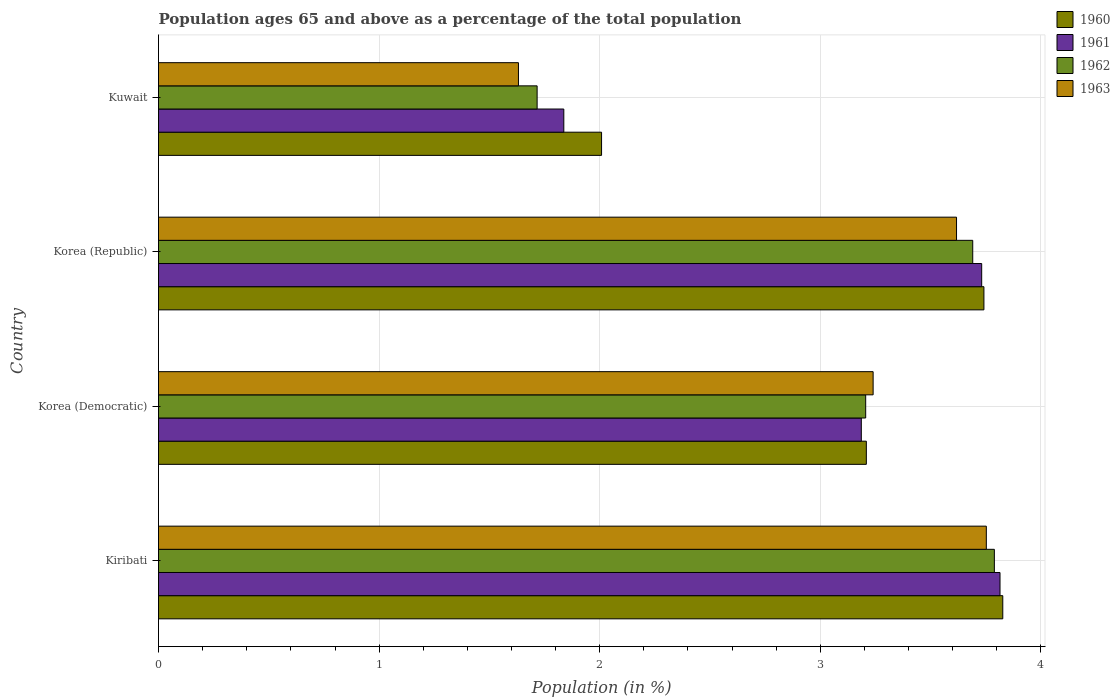How many different coloured bars are there?
Offer a terse response. 4. How many bars are there on the 4th tick from the top?
Ensure brevity in your answer.  4. What is the label of the 3rd group of bars from the top?
Give a very brief answer. Korea (Democratic). In how many cases, is the number of bars for a given country not equal to the number of legend labels?
Offer a very short reply. 0. What is the percentage of the population ages 65 and above in 1961 in Kuwait?
Keep it short and to the point. 1.84. Across all countries, what is the maximum percentage of the population ages 65 and above in 1962?
Your response must be concise. 3.79. Across all countries, what is the minimum percentage of the population ages 65 and above in 1963?
Your response must be concise. 1.63. In which country was the percentage of the population ages 65 and above in 1963 maximum?
Your answer should be compact. Kiribati. In which country was the percentage of the population ages 65 and above in 1962 minimum?
Provide a short and direct response. Kuwait. What is the total percentage of the population ages 65 and above in 1963 in the graph?
Give a very brief answer. 12.24. What is the difference between the percentage of the population ages 65 and above in 1960 in Korea (Democratic) and that in Korea (Republic)?
Your answer should be compact. -0.53. What is the difference between the percentage of the population ages 65 and above in 1961 in Kuwait and the percentage of the population ages 65 and above in 1962 in Korea (Republic)?
Make the answer very short. -1.85. What is the average percentage of the population ages 65 and above in 1961 per country?
Your response must be concise. 3.14. What is the difference between the percentage of the population ages 65 and above in 1961 and percentage of the population ages 65 and above in 1963 in Kuwait?
Your answer should be compact. 0.21. In how many countries, is the percentage of the population ages 65 and above in 1960 greater than 1.6 ?
Provide a succinct answer. 4. What is the ratio of the percentage of the population ages 65 and above in 1962 in Korea (Democratic) to that in Kuwait?
Make the answer very short. 1.87. Is the percentage of the population ages 65 and above in 1960 in Korea (Democratic) less than that in Korea (Republic)?
Provide a short and direct response. Yes. Is the difference between the percentage of the population ages 65 and above in 1961 in Korea (Democratic) and Kuwait greater than the difference between the percentage of the population ages 65 and above in 1963 in Korea (Democratic) and Kuwait?
Your answer should be compact. No. What is the difference between the highest and the second highest percentage of the population ages 65 and above in 1960?
Make the answer very short. 0.09. What is the difference between the highest and the lowest percentage of the population ages 65 and above in 1960?
Your response must be concise. 1.82. In how many countries, is the percentage of the population ages 65 and above in 1963 greater than the average percentage of the population ages 65 and above in 1963 taken over all countries?
Keep it short and to the point. 3. Is it the case that in every country, the sum of the percentage of the population ages 65 and above in 1961 and percentage of the population ages 65 and above in 1960 is greater than the sum of percentage of the population ages 65 and above in 1962 and percentage of the population ages 65 and above in 1963?
Your answer should be very brief. No. What does the 2nd bar from the top in Korea (Democratic) represents?
Keep it short and to the point. 1962. How many countries are there in the graph?
Your answer should be compact. 4. Does the graph contain any zero values?
Give a very brief answer. No. Does the graph contain grids?
Keep it short and to the point. Yes. Where does the legend appear in the graph?
Provide a succinct answer. Top right. How many legend labels are there?
Offer a very short reply. 4. How are the legend labels stacked?
Offer a very short reply. Vertical. What is the title of the graph?
Keep it short and to the point. Population ages 65 and above as a percentage of the total population. Does "2010" appear as one of the legend labels in the graph?
Your answer should be compact. No. What is the label or title of the Y-axis?
Make the answer very short. Country. What is the Population (in %) of 1960 in Kiribati?
Give a very brief answer. 3.83. What is the Population (in %) in 1961 in Kiribati?
Keep it short and to the point. 3.81. What is the Population (in %) in 1962 in Kiribati?
Offer a terse response. 3.79. What is the Population (in %) of 1963 in Kiribati?
Your answer should be compact. 3.75. What is the Population (in %) of 1960 in Korea (Democratic)?
Offer a terse response. 3.21. What is the Population (in %) in 1961 in Korea (Democratic)?
Make the answer very short. 3.19. What is the Population (in %) in 1962 in Korea (Democratic)?
Ensure brevity in your answer.  3.21. What is the Population (in %) in 1963 in Korea (Democratic)?
Provide a short and direct response. 3.24. What is the Population (in %) in 1960 in Korea (Republic)?
Make the answer very short. 3.74. What is the Population (in %) in 1961 in Korea (Republic)?
Your response must be concise. 3.73. What is the Population (in %) of 1962 in Korea (Republic)?
Your answer should be very brief. 3.69. What is the Population (in %) of 1963 in Korea (Republic)?
Provide a short and direct response. 3.62. What is the Population (in %) in 1960 in Kuwait?
Provide a succinct answer. 2.01. What is the Population (in %) in 1961 in Kuwait?
Offer a very short reply. 1.84. What is the Population (in %) of 1962 in Kuwait?
Provide a short and direct response. 1.72. What is the Population (in %) of 1963 in Kuwait?
Keep it short and to the point. 1.63. Across all countries, what is the maximum Population (in %) in 1960?
Give a very brief answer. 3.83. Across all countries, what is the maximum Population (in %) of 1961?
Provide a short and direct response. 3.81. Across all countries, what is the maximum Population (in %) of 1962?
Your answer should be very brief. 3.79. Across all countries, what is the maximum Population (in %) in 1963?
Your answer should be very brief. 3.75. Across all countries, what is the minimum Population (in %) in 1960?
Offer a terse response. 2.01. Across all countries, what is the minimum Population (in %) of 1961?
Make the answer very short. 1.84. Across all countries, what is the minimum Population (in %) in 1962?
Provide a succinct answer. 1.72. Across all countries, what is the minimum Population (in %) of 1963?
Offer a very short reply. 1.63. What is the total Population (in %) of 1960 in the graph?
Offer a terse response. 12.79. What is the total Population (in %) of 1961 in the graph?
Give a very brief answer. 12.57. What is the total Population (in %) of 1962 in the graph?
Give a very brief answer. 12.4. What is the total Population (in %) in 1963 in the graph?
Your response must be concise. 12.24. What is the difference between the Population (in %) of 1960 in Kiribati and that in Korea (Democratic)?
Give a very brief answer. 0.62. What is the difference between the Population (in %) in 1961 in Kiribati and that in Korea (Democratic)?
Offer a very short reply. 0.63. What is the difference between the Population (in %) in 1962 in Kiribati and that in Korea (Democratic)?
Offer a terse response. 0.58. What is the difference between the Population (in %) in 1963 in Kiribati and that in Korea (Democratic)?
Provide a succinct answer. 0.51. What is the difference between the Population (in %) in 1960 in Kiribati and that in Korea (Republic)?
Your response must be concise. 0.09. What is the difference between the Population (in %) of 1961 in Kiribati and that in Korea (Republic)?
Your answer should be compact. 0.08. What is the difference between the Population (in %) of 1962 in Kiribati and that in Korea (Republic)?
Your answer should be compact. 0.1. What is the difference between the Population (in %) in 1963 in Kiribati and that in Korea (Republic)?
Your answer should be very brief. 0.14. What is the difference between the Population (in %) of 1960 in Kiribati and that in Kuwait?
Provide a short and direct response. 1.82. What is the difference between the Population (in %) of 1961 in Kiribati and that in Kuwait?
Ensure brevity in your answer.  1.98. What is the difference between the Population (in %) of 1962 in Kiribati and that in Kuwait?
Your response must be concise. 2.07. What is the difference between the Population (in %) of 1963 in Kiribati and that in Kuwait?
Keep it short and to the point. 2.12. What is the difference between the Population (in %) of 1960 in Korea (Democratic) and that in Korea (Republic)?
Your response must be concise. -0.53. What is the difference between the Population (in %) in 1961 in Korea (Democratic) and that in Korea (Republic)?
Your answer should be very brief. -0.55. What is the difference between the Population (in %) of 1962 in Korea (Democratic) and that in Korea (Republic)?
Provide a succinct answer. -0.49. What is the difference between the Population (in %) of 1963 in Korea (Democratic) and that in Korea (Republic)?
Your answer should be very brief. -0.38. What is the difference between the Population (in %) in 1960 in Korea (Democratic) and that in Kuwait?
Offer a terse response. 1.2. What is the difference between the Population (in %) in 1961 in Korea (Democratic) and that in Kuwait?
Your response must be concise. 1.35. What is the difference between the Population (in %) in 1962 in Korea (Democratic) and that in Kuwait?
Provide a short and direct response. 1.49. What is the difference between the Population (in %) of 1963 in Korea (Democratic) and that in Kuwait?
Provide a short and direct response. 1.61. What is the difference between the Population (in %) in 1960 in Korea (Republic) and that in Kuwait?
Your response must be concise. 1.73. What is the difference between the Population (in %) in 1961 in Korea (Republic) and that in Kuwait?
Your response must be concise. 1.89. What is the difference between the Population (in %) in 1962 in Korea (Republic) and that in Kuwait?
Offer a terse response. 1.97. What is the difference between the Population (in %) in 1963 in Korea (Republic) and that in Kuwait?
Your answer should be compact. 1.99. What is the difference between the Population (in %) in 1960 in Kiribati and the Population (in %) in 1961 in Korea (Democratic)?
Offer a very short reply. 0.64. What is the difference between the Population (in %) in 1960 in Kiribati and the Population (in %) in 1962 in Korea (Democratic)?
Keep it short and to the point. 0.62. What is the difference between the Population (in %) of 1960 in Kiribati and the Population (in %) of 1963 in Korea (Democratic)?
Give a very brief answer. 0.59. What is the difference between the Population (in %) in 1961 in Kiribati and the Population (in %) in 1962 in Korea (Democratic)?
Ensure brevity in your answer.  0.61. What is the difference between the Population (in %) in 1961 in Kiribati and the Population (in %) in 1963 in Korea (Democratic)?
Ensure brevity in your answer.  0.58. What is the difference between the Population (in %) in 1962 in Kiribati and the Population (in %) in 1963 in Korea (Democratic)?
Your answer should be very brief. 0.55. What is the difference between the Population (in %) of 1960 in Kiribati and the Population (in %) of 1961 in Korea (Republic)?
Keep it short and to the point. 0.1. What is the difference between the Population (in %) of 1960 in Kiribati and the Population (in %) of 1962 in Korea (Republic)?
Provide a succinct answer. 0.14. What is the difference between the Population (in %) of 1960 in Kiribati and the Population (in %) of 1963 in Korea (Republic)?
Your answer should be compact. 0.21. What is the difference between the Population (in %) of 1961 in Kiribati and the Population (in %) of 1962 in Korea (Republic)?
Keep it short and to the point. 0.12. What is the difference between the Population (in %) in 1961 in Kiribati and the Population (in %) in 1963 in Korea (Republic)?
Provide a short and direct response. 0.2. What is the difference between the Population (in %) of 1962 in Kiribati and the Population (in %) of 1963 in Korea (Republic)?
Ensure brevity in your answer.  0.17. What is the difference between the Population (in %) in 1960 in Kiribati and the Population (in %) in 1961 in Kuwait?
Offer a very short reply. 1.99. What is the difference between the Population (in %) of 1960 in Kiribati and the Population (in %) of 1962 in Kuwait?
Offer a terse response. 2.11. What is the difference between the Population (in %) of 1960 in Kiribati and the Population (in %) of 1963 in Kuwait?
Provide a short and direct response. 2.2. What is the difference between the Population (in %) in 1961 in Kiribati and the Population (in %) in 1962 in Kuwait?
Your response must be concise. 2.1. What is the difference between the Population (in %) of 1961 in Kiribati and the Population (in %) of 1963 in Kuwait?
Keep it short and to the point. 2.18. What is the difference between the Population (in %) of 1962 in Kiribati and the Population (in %) of 1963 in Kuwait?
Make the answer very short. 2.16. What is the difference between the Population (in %) of 1960 in Korea (Democratic) and the Population (in %) of 1961 in Korea (Republic)?
Offer a terse response. -0.52. What is the difference between the Population (in %) of 1960 in Korea (Democratic) and the Population (in %) of 1962 in Korea (Republic)?
Give a very brief answer. -0.48. What is the difference between the Population (in %) in 1960 in Korea (Democratic) and the Population (in %) in 1963 in Korea (Republic)?
Your answer should be compact. -0.41. What is the difference between the Population (in %) in 1961 in Korea (Democratic) and the Population (in %) in 1962 in Korea (Republic)?
Your response must be concise. -0.51. What is the difference between the Population (in %) of 1961 in Korea (Democratic) and the Population (in %) of 1963 in Korea (Republic)?
Give a very brief answer. -0.43. What is the difference between the Population (in %) of 1962 in Korea (Democratic) and the Population (in %) of 1963 in Korea (Republic)?
Provide a succinct answer. -0.41. What is the difference between the Population (in %) of 1960 in Korea (Democratic) and the Population (in %) of 1961 in Kuwait?
Your response must be concise. 1.37. What is the difference between the Population (in %) of 1960 in Korea (Democratic) and the Population (in %) of 1962 in Kuwait?
Provide a succinct answer. 1.49. What is the difference between the Population (in %) of 1960 in Korea (Democratic) and the Population (in %) of 1963 in Kuwait?
Give a very brief answer. 1.58. What is the difference between the Population (in %) in 1961 in Korea (Democratic) and the Population (in %) in 1962 in Kuwait?
Keep it short and to the point. 1.47. What is the difference between the Population (in %) of 1961 in Korea (Democratic) and the Population (in %) of 1963 in Kuwait?
Your answer should be compact. 1.55. What is the difference between the Population (in %) in 1962 in Korea (Democratic) and the Population (in %) in 1963 in Kuwait?
Offer a very short reply. 1.57. What is the difference between the Population (in %) of 1960 in Korea (Republic) and the Population (in %) of 1961 in Kuwait?
Make the answer very short. 1.9. What is the difference between the Population (in %) of 1960 in Korea (Republic) and the Population (in %) of 1962 in Kuwait?
Provide a succinct answer. 2.03. What is the difference between the Population (in %) of 1960 in Korea (Republic) and the Population (in %) of 1963 in Kuwait?
Your response must be concise. 2.11. What is the difference between the Population (in %) in 1961 in Korea (Republic) and the Population (in %) in 1962 in Kuwait?
Keep it short and to the point. 2.02. What is the difference between the Population (in %) in 1961 in Korea (Republic) and the Population (in %) in 1963 in Kuwait?
Give a very brief answer. 2.1. What is the difference between the Population (in %) of 1962 in Korea (Republic) and the Population (in %) of 1963 in Kuwait?
Your response must be concise. 2.06. What is the average Population (in %) in 1960 per country?
Your answer should be very brief. 3.2. What is the average Population (in %) of 1961 per country?
Provide a succinct answer. 3.14. What is the average Population (in %) in 1962 per country?
Your response must be concise. 3.1. What is the average Population (in %) of 1963 per country?
Ensure brevity in your answer.  3.06. What is the difference between the Population (in %) of 1960 and Population (in %) of 1961 in Kiribati?
Ensure brevity in your answer.  0.01. What is the difference between the Population (in %) of 1960 and Population (in %) of 1962 in Kiribati?
Offer a very short reply. 0.04. What is the difference between the Population (in %) in 1960 and Population (in %) in 1963 in Kiribati?
Make the answer very short. 0.07. What is the difference between the Population (in %) of 1961 and Population (in %) of 1962 in Kiribati?
Provide a short and direct response. 0.03. What is the difference between the Population (in %) in 1961 and Population (in %) in 1963 in Kiribati?
Make the answer very short. 0.06. What is the difference between the Population (in %) in 1962 and Population (in %) in 1963 in Kiribati?
Provide a succinct answer. 0.04. What is the difference between the Population (in %) of 1960 and Population (in %) of 1961 in Korea (Democratic)?
Ensure brevity in your answer.  0.02. What is the difference between the Population (in %) of 1960 and Population (in %) of 1962 in Korea (Democratic)?
Provide a short and direct response. 0. What is the difference between the Population (in %) in 1960 and Population (in %) in 1963 in Korea (Democratic)?
Your answer should be compact. -0.03. What is the difference between the Population (in %) of 1961 and Population (in %) of 1962 in Korea (Democratic)?
Offer a very short reply. -0.02. What is the difference between the Population (in %) of 1961 and Population (in %) of 1963 in Korea (Democratic)?
Give a very brief answer. -0.05. What is the difference between the Population (in %) in 1962 and Population (in %) in 1963 in Korea (Democratic)?
Your answer should be very brief. -0.03. What is the difference between the Population (in %) of 1960 and Population (in %) of 1961 in Korea (Republic)?
Your response must be concise. 0.01. What is the difference between the Population (in %) of 1960 and Population (in %) of 1962 in Korea (Republic)?
Provide a short and direct response. 0.05. What is the difference between the Population (in %) of 1960 and Population (in %) of 1963 in Korea (Republic)?
Give a very brief answer. 0.12. What is the difference between the Population (in %) in 1961 and Population (in %) in 1962 in Korea (Republic)?
Your answer should be compact. 0.04. What is the difference between the Population (in %) of 1961 and Population (in %) of 1963 in Korea (Republic)?
Your answer should be compact. 0.11. What is the difference between the Population (in %) of 1962 and Population (in %) of 1963 in Korea (Republic)?
Provide a succinct answer. 0.07. What is the difference between the Population (in %) in 1960 and Population (in %) in 1961 in Kuwait?
Provide a short and direct response. 0.17. What is the difference between the Population (in %) in 1960 and Population (in %) in 1962 in Kuwait?
Keep it short and to the point. 0.29. What is the difference between the Population (in %) of 1960 and Population (in %) of 1963 in Kuwait?
Provide a short and direct response. 0.38. What is the difference between the Population (in %) in 1961 and Population (in %) in 1962 in Kuwait?
Your answer should be compact. 0.12. What is the difference between the Population (in %) in 1961 and Population (in %) in 1963 in Kuwait?
Keep it short and to the point. 0.21. What is the difference between the Population (in %) in 1962 and Population (in %) in 1963 in Kuwait?
Your answer should be very brief. 0.08. What is the ratio of the Population (in %) of 1960 in Kiribati to that in Korea (Democratic)?
Keep it short and to the point. 1.19. What is the ratio of the Population (in %) in 1961 in Kiribati to that in Korea (Democratic)?
Offer a very short reply. 1.2. What is the ratio of the Population (in %) of 1962 in Kiribati to that in Korea (Democratic)?
Provide a succinct answer. 1.18. What is the ratio of the Population (in %) in 1963 in Kiribati to that in Korea (Democratic)?
Keep it short and to the point. 1.16. What is the ratio of the Population (in %) of 1960 in Kiribati to that in Korea (Republic)?
Your answer should be very brief. 1.02. What is the ratio of the Population (in %) of 1961 in Kiribati to that in Korea (Republic)?
Give a very brief answer. 1.02. What is the ratio of the Population (in %) of 1962 in Kiribati to that in Korea (Republic)?
Keep it short and to the point. 1.03. What is the ratio of the Population (in %) in 1963 in Kiribati to that in Korea (Republic)?
Provide a succinct answer. 1.04. What is the ratio of the Population (in %) of 1960 in Kiribati to that in Kuwait?
Provide a short and direct response. 1.91. What is the ratio of the Population (in %) of 1961 in Kiribati to that in Kuwait?
Provide a succinct answer. 2.08. What is the ratio of the Population (in %) in 1962 in Kiribati to that in Kuwait?
Ensure brevity in your answer.  2.21. What is the ratio of the Population (in %) of 1963 in Kiribati to that in Kuwait?
Provide a succinct answer. 2.3. What is the ratio of the Population (in %) of 1960 in Korea (Democratic) to that in Korea (Republic)?
Give a very brief answer. 0.86. What is the ratio of the Population (in %) of 1961 in Korea (Democratic) to that in Korea (Republic)?
Keep it short and to the point. 0.85. What is the ratio of the Population (in %) of 1962 in Korea (Democratic) to that in Korea (Republic)?
Your response must be concise. 0.87. What is the ratio of the Population (in %) of 1963 in Korea (Democratic) to that in Korea (Republic)?
Make the answer very short. 0.9. What is the ratio of the Population (in %) in 1960 in Korea (Democratic) to that in Kuwait?
Offer a very short reply. 1.6. What is the ratio of the Population (in %) of 1961 in Korea (Democratic) to that in Kuwait?
Make the answer very short. 1.73. What is the ratio of the Population (in %) of 1962 in Korea (Democratic) to that in Kuwait?
Provide a short and direct response. 1.87. What is the ratio of the Population (in %) in 1963 in Korea (Democratic) to that in Kuwait?
Make the answer very short. 1.99. What is the ratio of the Population (in %) of 1960 in Korea (Republic) to that in Kuwait?
Ensure brevity in your answer.  1.86. What is the ratio of the Population (in %) in 1961 in Korea (Republic) to that in Kuwait?
Your answer should be very brief. 2.03. What is the ratio of the Population (in %) in 1962 in Korea (Republic) to that in Kuwait?
Offer a very short reply. 2.15. What is the ratio of the Population (in %) in 1963 in Korea (Republic) to that in Kuwait?
Make the answer very short. 2.22. What is the difference between the highest and the second highest Population (in %) in 1960?
Give a very brief answer. 0.09. What is the difference between the highest and the second highest Population (in %) in 1961?
Offer a terse response. 0.08. What is the difference between the highest and the second highest Population (in %) in 1962?
Give a very brief answer. 0.1. What is the difference between the highest and the second highest Population (in %) of 1963?
Give a very brief answer. 0.14. What is the difference between the highest and the lowest Population (in %) in 1960?
Keep it short and to the point. 1.82. What is the difference between the highest and the lowest Population (in %) of 1961?
Offer a very short reply. 1.98. What is the difference between the highest and the lowest Population (in %) of 1962?
Make the answer very short. 2.07. What is the difference between the highest and the lowest Population (in %) of 1963?
Offer a terse response. 2.12. 